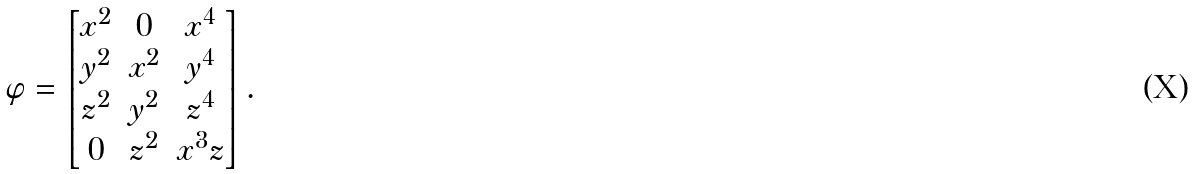<formula> <loc_0><loc_0><loc_500><loc_500>\varphi = \begin{bmatrix} x ^ { 2 } & 0 & x ^ { 4 } \\ y ^ { 2 } & x ^ { 2 } & y ^ { 4 } \\ z ^ { 2 } & y ^ { 2 } & z ^ { 4 } \\ 0 & z ^ { 2 } & x ^ { 3 } z \end{bmatrix} .</formula> 